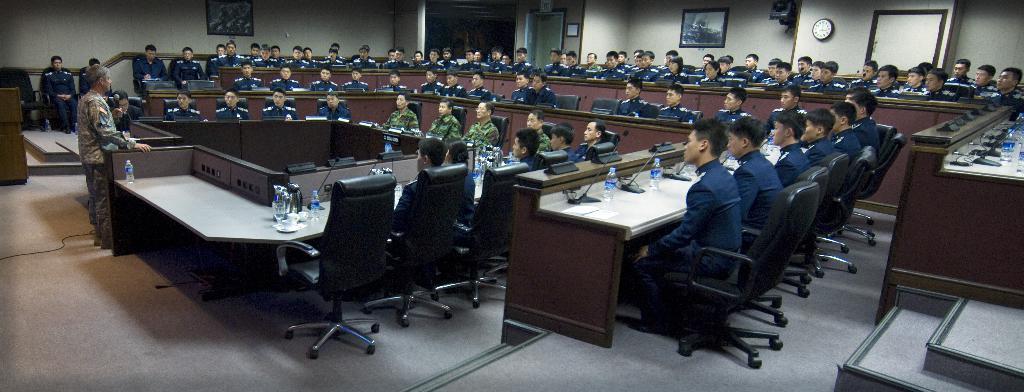How would you summarize this image in a sentence or two? In this picture there are different types of tables and chairs where all the people are are sitting and the one who is left side of the image is addressing the people those who are sitting in a room, it seems to be a conference meet or an organisation. 